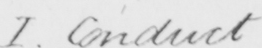What does this handwritten line say? I . Conduct 